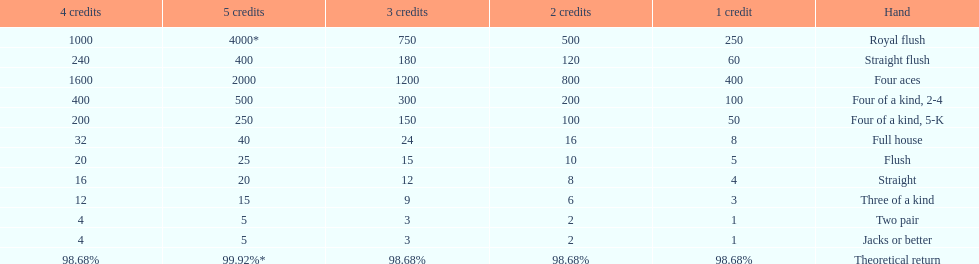Which is a higher standing hand: a straight or a flush? Flush. 